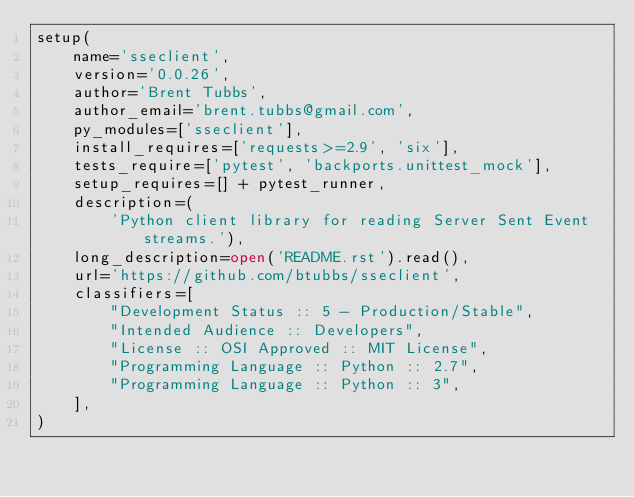Convert code to text. <code><loc_0><loc_0><loc_500><loc_500><_Python_>setup(
    name='sseclient',
    version='0.0.26',
    author='Brent Tubbs',
    author_email='brent.tubbs@gmail.com',
    py_modules=['sseclient'],
    install_requires=['requests>=2.9', 'six'],
    tests_require=['pytest', 'backports.unittest_mock'],
    setup_requires=[] + pytest_runner,
    description=(
        'Python client library for reading Server Sent Event streams.'),
    long_description=open('README.rst').read(),
    url='https://github.com/btubbs/sseclient',
    classifiers=[
        "Development Status :: 5 - Production/Stable",
        "Intended Audience :: Developers",
        "License :: OSI Approved :: MIT License",
        "Programming Language :: Python :: 2.7",
        "Programming Language :: Python :: 3",
    ],
)
</code> 